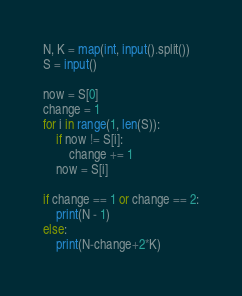<code> <loc_0><loc_0><loc_500><loc_500><_Python_>N, K = map(int, input().split())
S = input()

now = S[0]
change = 1
for i in range(1, len(S)):
    if now != S[i]:
        change += 1
    now = S[i]

if change == 1 or change == 2:
    print(N - 1)
else:
    print(N-change+2*K)
</code> 